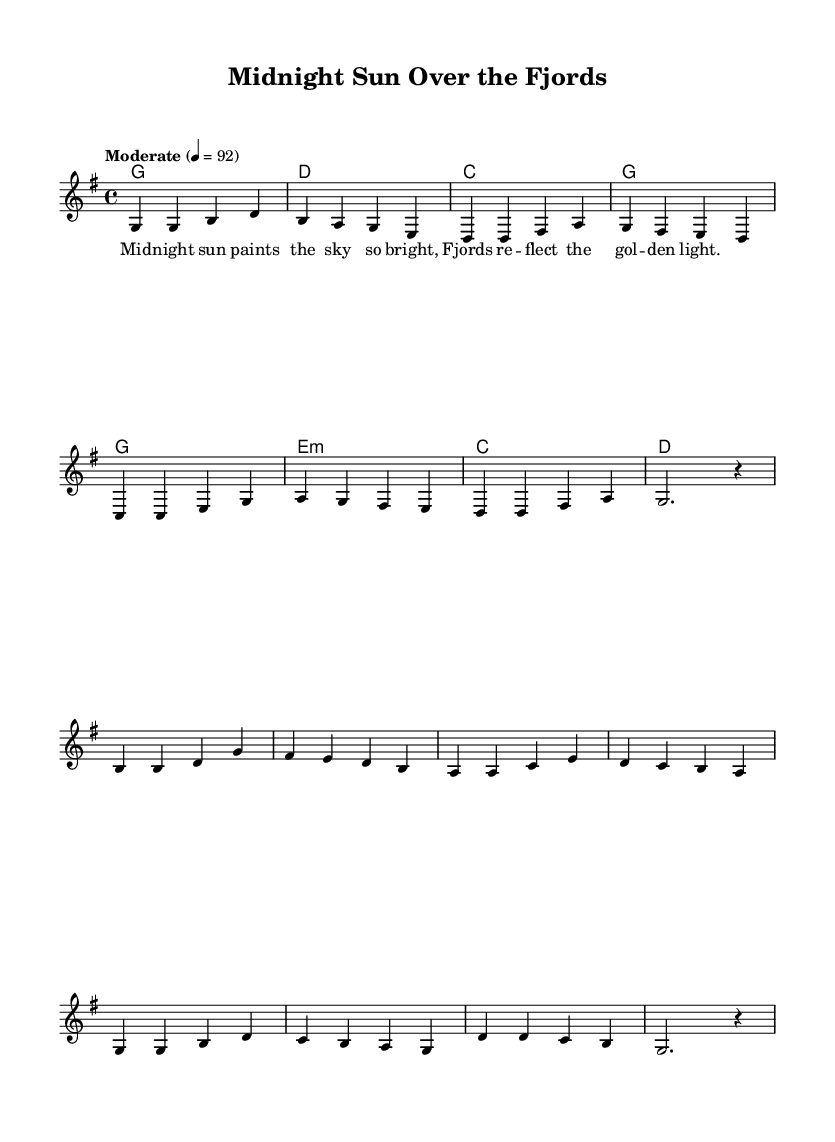What is the key signature of this music? The key signature indicates G major, which has one sharp (F#). This is identified by looking at the beginning of the staff where the key signature is placed.
Answer: G major What is the time signature of the score? The time signature is 4/4, which means there are four beats in each measure, and a quarter note gets one beat. This can be found at the beginning of the score, right next to the key signature.
Answer: 4/4 What is the tempo marking of this piece? The tempo marking is "Moderate" set at a speed of 92 beats per minute. This is noted near the beginning of the score, which indicates the speed for the performance.
Answer: Moderate How many measures are in the verse section? There are eight measures in the verse section. This can be counted by looking at the notation and identifying the number of complete sets between the bar lines.
Answer: Eight What is the last note of the chorus? The last note of the chorus is a rest. This is determined by looking at the final notation of the chorus line where it ends, indicating no sound is produced.
Answer: Rest In which section does the lyric "Oh, Scandinavia, land so fair" appear? This lyric appears in the chorus section. This can be identified by referencing the labels associated with the lyrical phrases in the score layout.
Answer: Chorus 